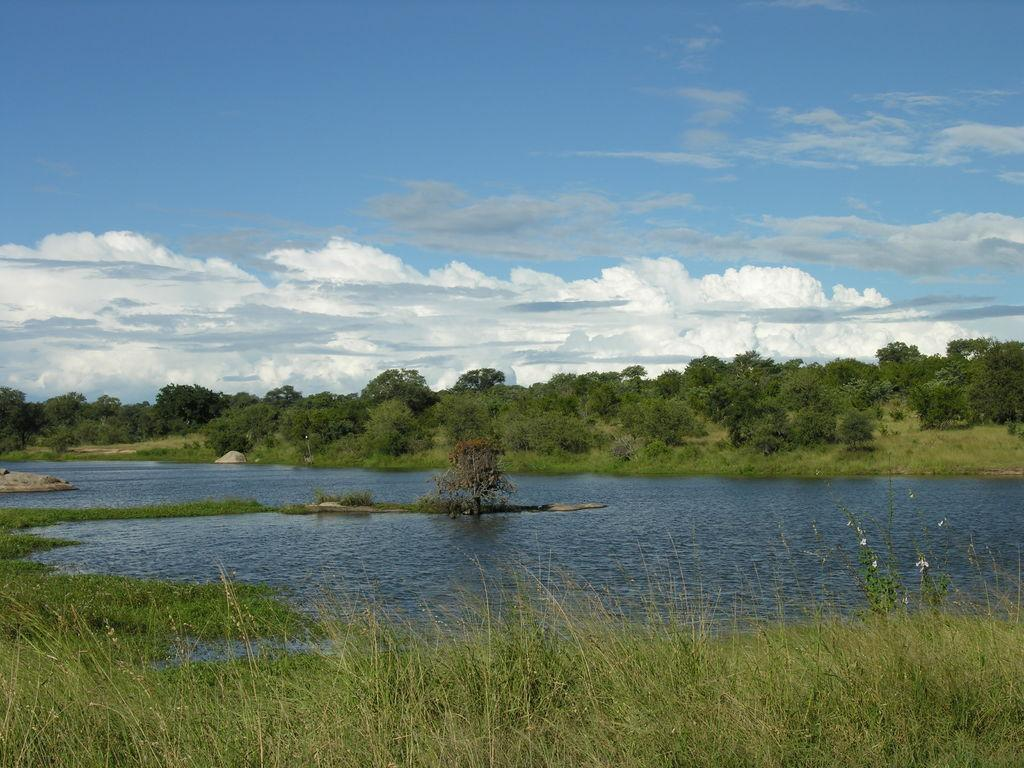What is the color of the sky in the image? The sky is blue in color. What can be seen in the sky besides the blue color? There are clouds visible in the image. What is the main feature of the image? The main feature of the image is water. What type of vegetation is near the water? Trees are present near the water. What type of ground is visible in the image? Grass is visible in the image. Can you tell me how many girls are washing their hands in the image? There are no girls or any hand-washing activity present in the image. 